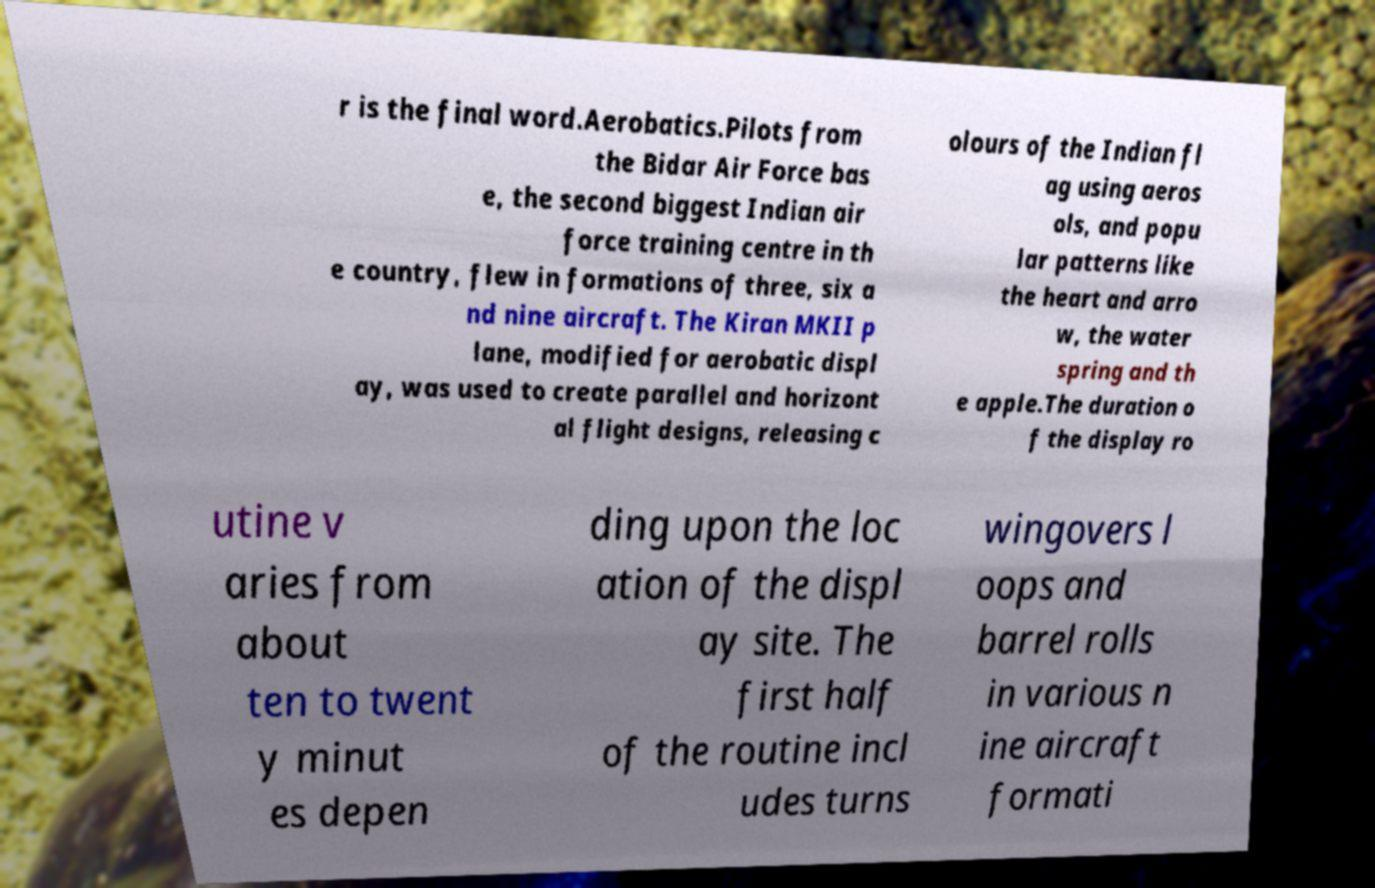Please read and relay the text visible in this image. What does it say? r is the final word.Aerobatics.Pilots from the Bidar Air Force bas e, the second biggest Indian air force training centre in th e country, flew in formations of three, six a nd nine aircraft. The Kiran MKII p lane, modified for aerobatic displ ay, was used to create parallel and horizont al flight designs, releasing c olours of the Indian fl ag using aeros ols, and popu lar patterns like the heart and arro w, the water spring and th e apple.The duration o f the display ro utine v aries from about ten to twent y minut es depen ding upon the loc ation of the displ ay site. The first half of the routine incl udes turns wingovers l oops and barrel rolls in various n ine aircraft formati 